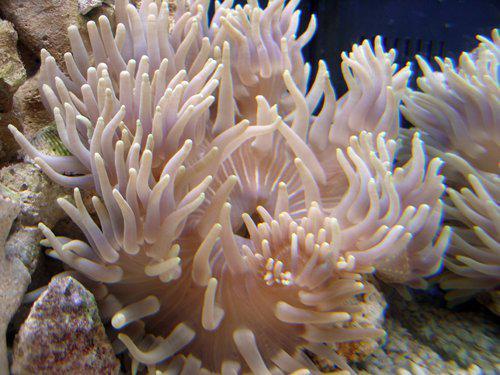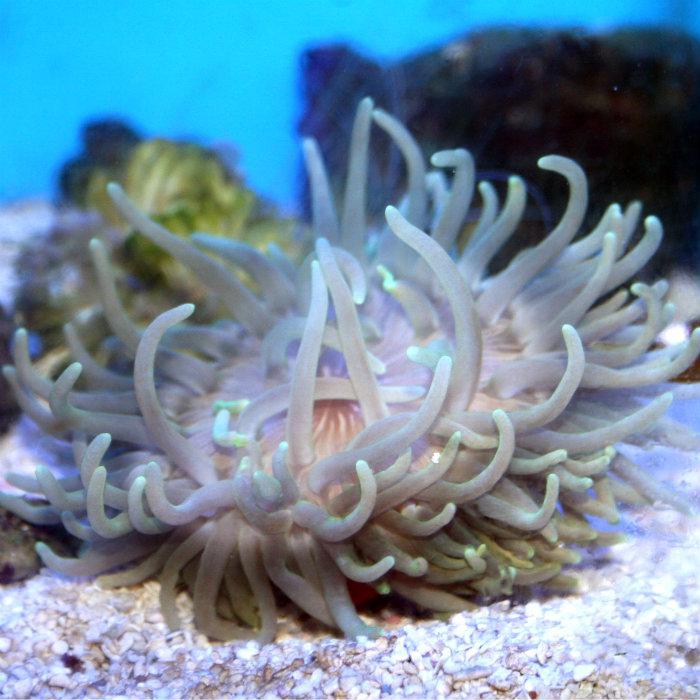The first image is the image on the left, the second image is the image on the right. Assess this claim about the two images: "There is a white anemone in one of the images.". Correct or not? Answer yes or no. Yes. 